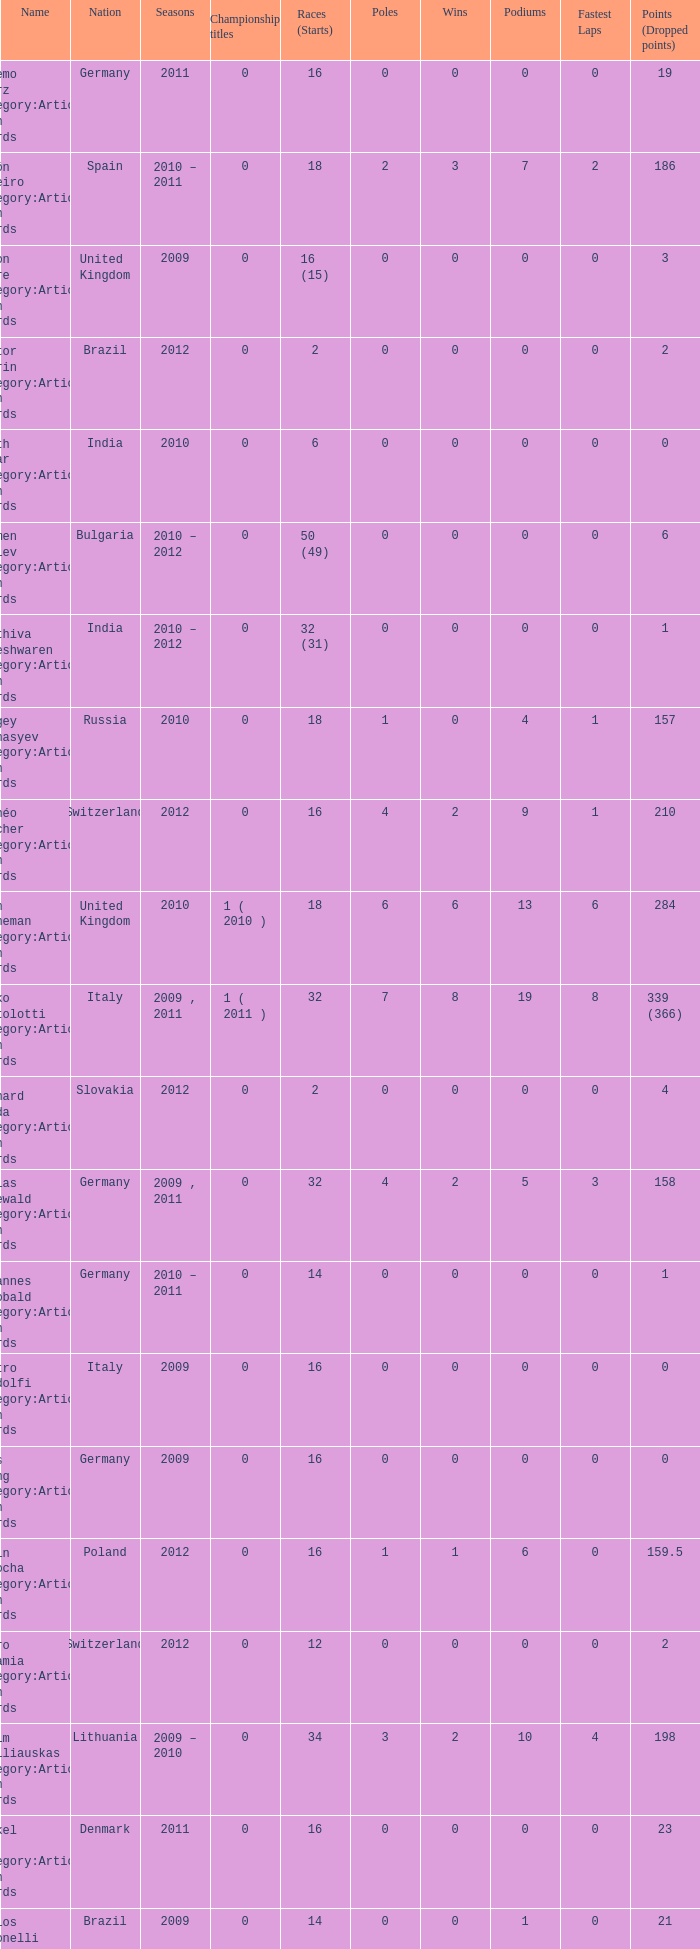What were the starts when the points dropped 18? 8.0. 